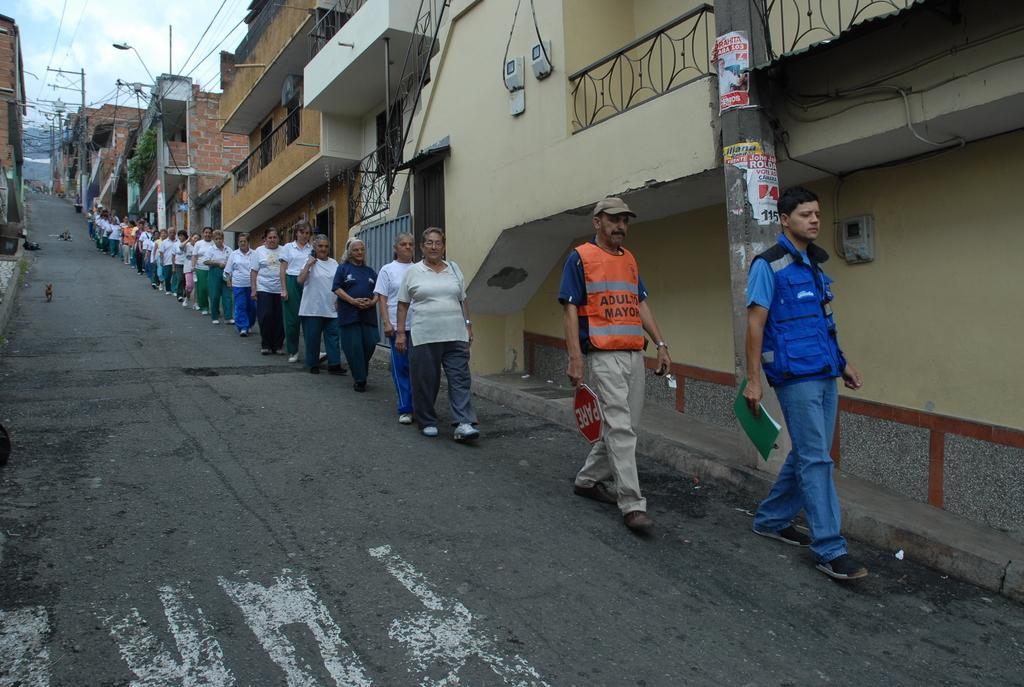Can you describe this image briefly? In this picture we can see a group of people walking on the road, dog, book, board, buildings, poles and in the background we can see the sky. 